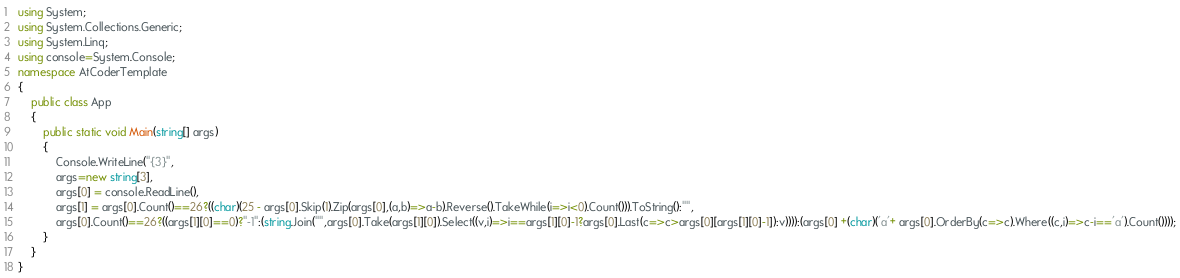Convert code to text. <code><loc_0><loc_0><loc_500><loc_500><_C#_>using System;
using System.Collections.Generic;
using System.Linq;
using console=System.Console;
namespace AtCoderTemplate
{
    public class App
    {
        public static void Main(string[] args)
        {
            Console.WriteLine("{3}",
            args=new string[3],
            args[0] = console.ReadLine(),
            args[1] = args[0].Count()==26?((char)(25 - args[0].Skip(1).Zip(args[0],(a,b)=>a-b).Reverse().TakeWhile(i=>i<0).Count())).ToString():"",
            args[0].Count()==26?((args[1][0]==0)?"-1":(string.Join("",args[0].Take(args[1][0]).Select((v,i)=>i==args[1][0]-1?args[0].Last(c=>c>args[0][args[1][0]-1]):v)))):(args[0] +(char)('a'+ args[0].OrderBy(c=>c).Where((c,i)=>c-i=='a').Count())));
        }
    }
}</code> 